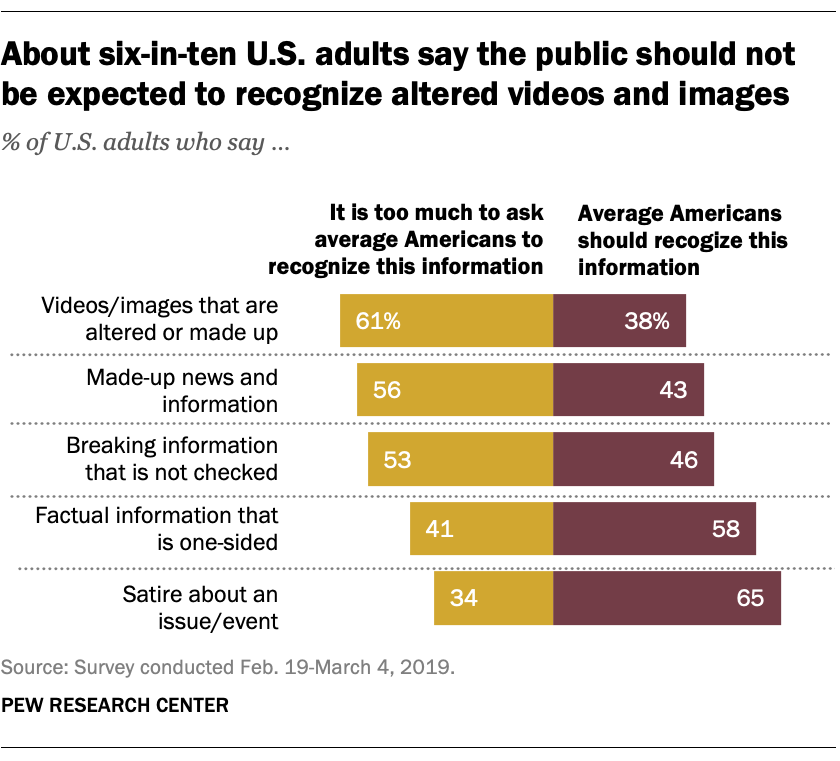Outline some significant characteristics in this image. According to opinions, the hardest recognizable situation is videos or images that are altered or made up, and the easiest recognizable one is satire about an issue or event. What is the second smallest bar value? It is 38.. 